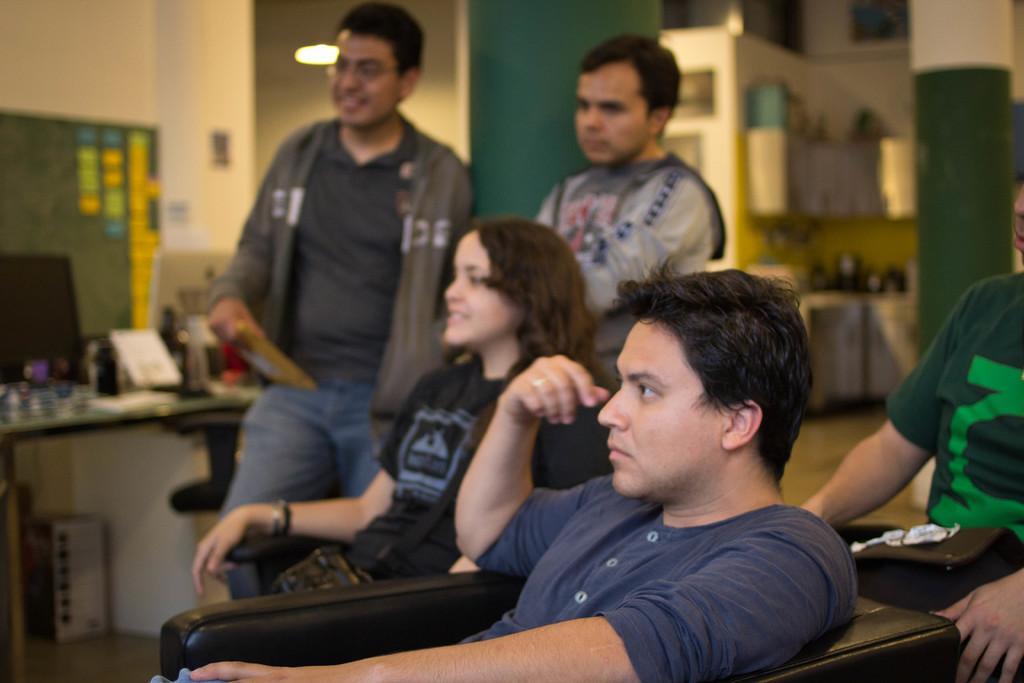Please provide a concise description of this image. In this image we can see one woman is sitting. She is wearing black color t-shirt. To the left side of the women, two men are sitting. One man is wearing grey color t-shirt and the other one is wearing green color t-shirt. Background of the image two men are standing. Left side of the image table is there. On table monitor and things are there. The walls of the room is in white and green color. 